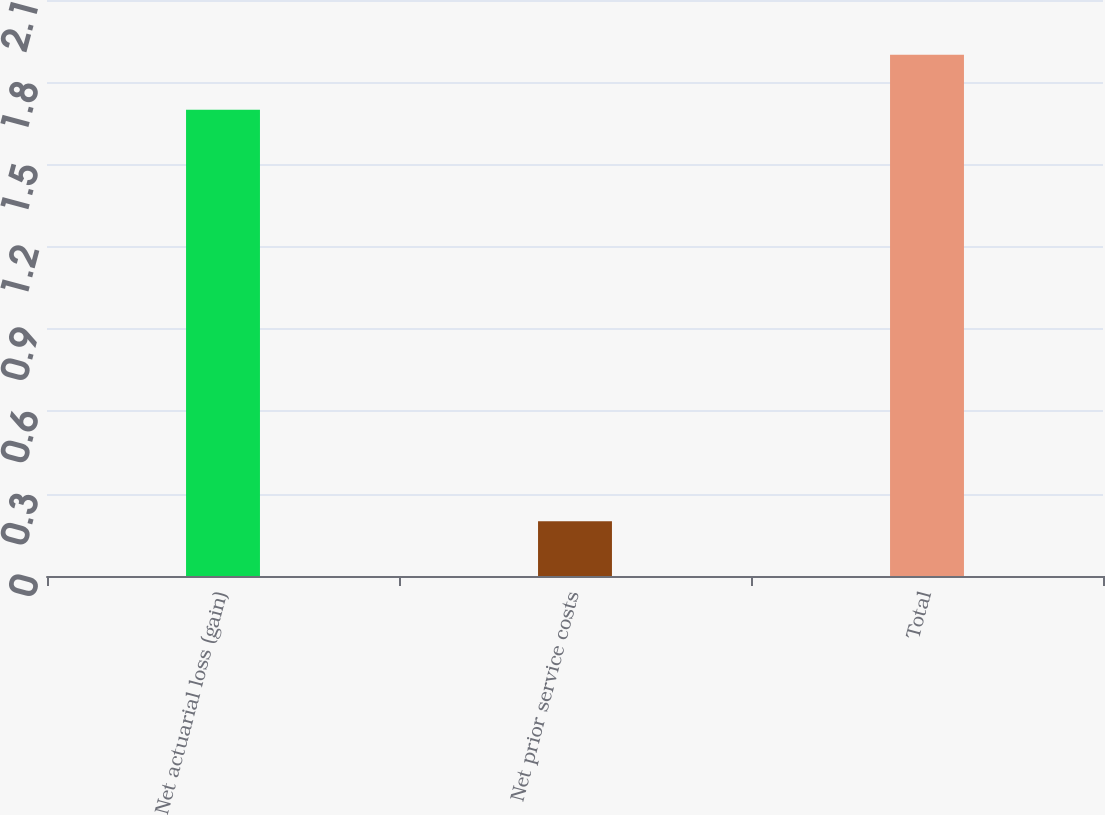<chart> <loc_0><loc_0><loc_500><loc_500><bar_chart><fcel>Net actuarial loss (gain)<fcel>Net prior service costs<fcel>Total<nl><fcel>1.7<fcel>0.2<fcel>1.9<nl></chart> 